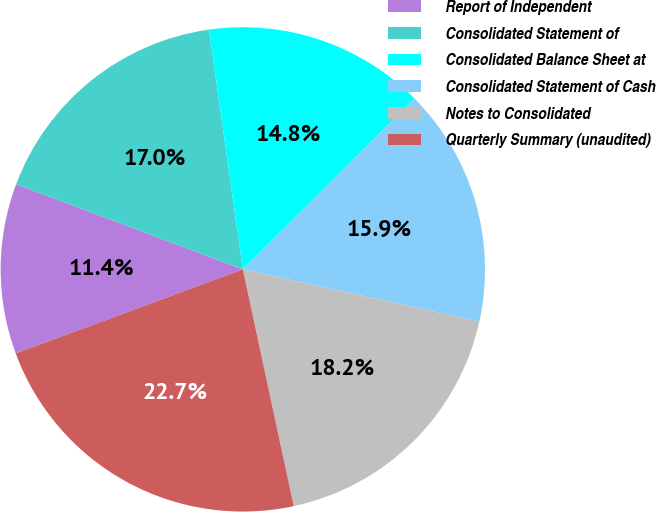<chart> <loc_0><loc_0><loc_500><loc_500><pie_chart><fcel>Report of Independent<fcel>Consolidated Statement of<fcel>Consolidated Balance Sheet at<fcel>Consolidated Statement of Cash<fcel>Notes to Consolidated<fcel>Quarterly Summary (unaudited)<nl><fcel>11.36%<fcel>17.05%<fcel>14.77%<fcel>15.91%<fcel>18.18%<fcel>22.73%<nl></chart> 